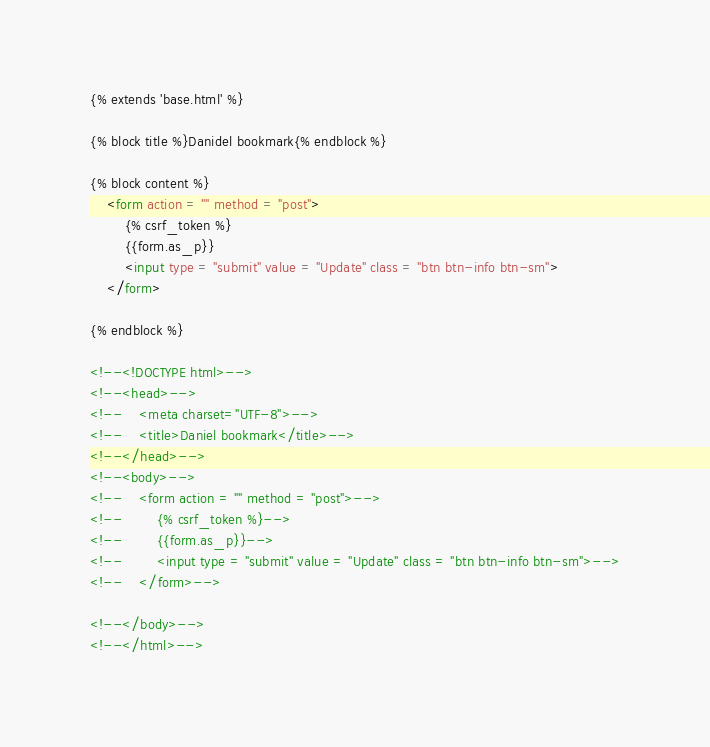<code> <loc_0><loc_0><loc_500><loc_500><_HTML_>{% extends 'base.html' %}

{% block title %}Danidel bookmark{% endblock %}

{% block content %}
    <form action = "" method = "post">
        {% csrf_token %}
        {{form.as_p}}
        <input type = "submit" value = "Update" class = "btn btn-info btn-sm">
    </form>

{% endblock %}

<!--<!DOCTYPE html>-->
<!--<head>-->
<!--    <meta charset="UTF-8">-->
<!--    <title>Daniel bookmark</title>-->
<!--</head>-->
<!--<body>-->
<!--    <form action = "" method = "post">-->
<!--        {% csrf_token %}-->
<!--        {{form.as_p}}-->
<!--        <input type = "submit" value = "Update" class = "btn btn-info btn-sm">-->
<!--    </form>-->

<!--</body>-->
<!--</html>--></code> 